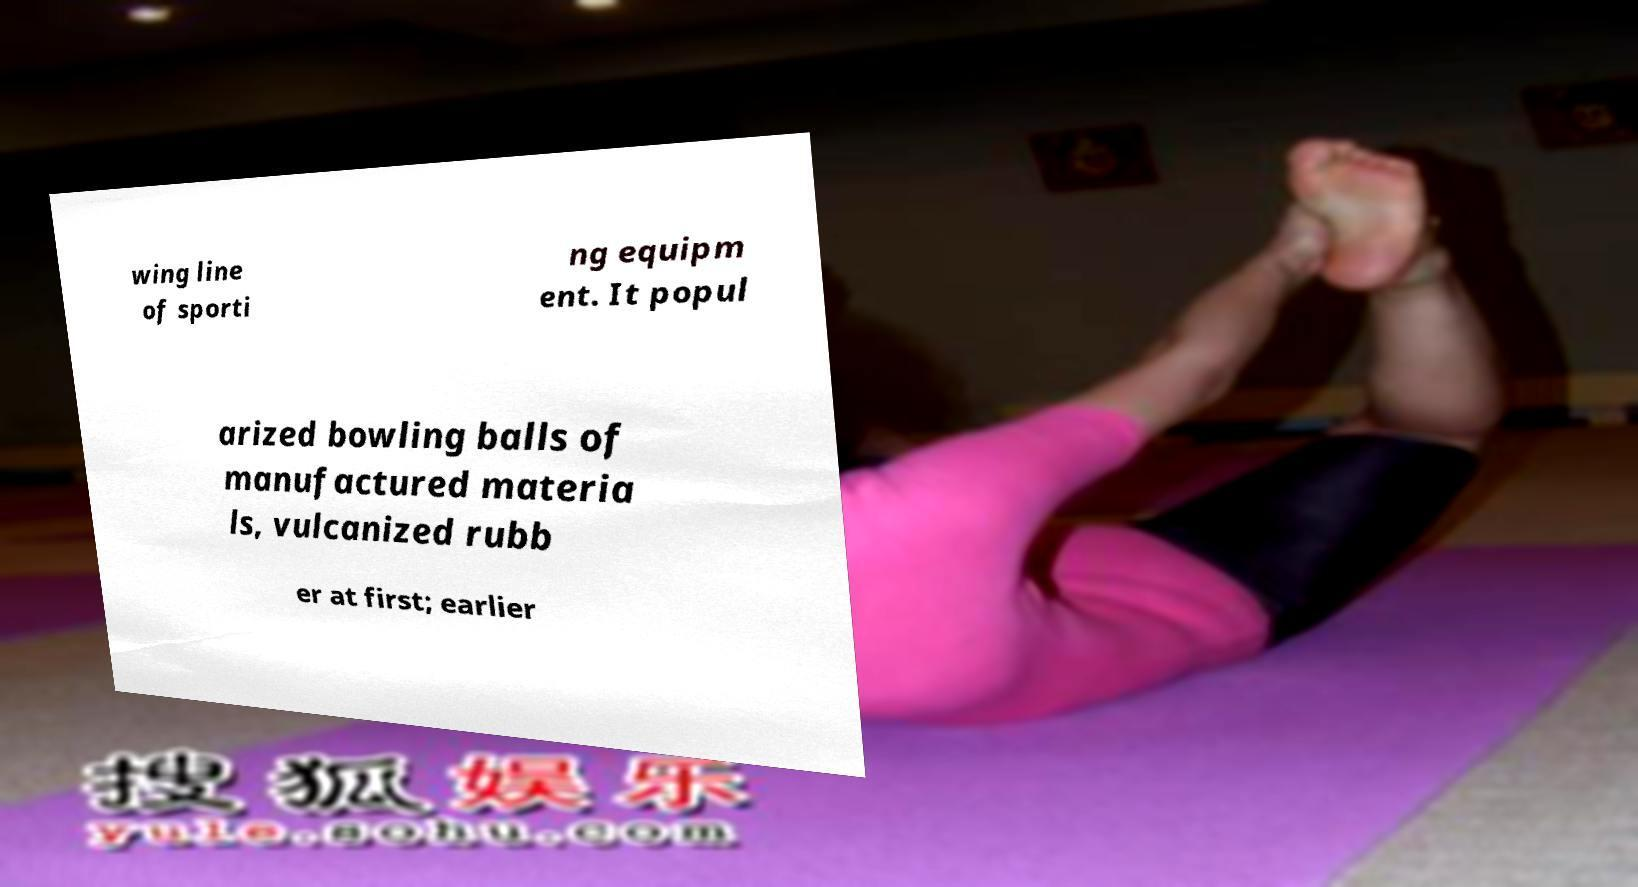I need the written content from this picture converted into text. Can you do that? wing line of sporti ng equipm ent. It popul arized bowling balls of manufactured materia ls, vulcanized rubb er at first; earlier 